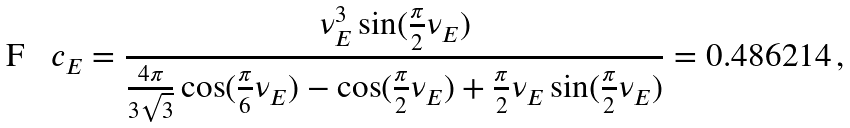<formula> <loc_0><loc_0><loc_500><loc_500>c _ { E } = \frac { \nu ^ { 3 } _ { E } \sin ( \frac { \pi } { 2 } \nu _ { E } ) } { \frac { 4 \pi } { 3 \sqrt { 3 } } \cos ( \frac { \pi } { 6 } \nu _ { E } ) - \cos ( \frac { \pi } { 2 } \nu _ { E } ) + \frac { \pi } { 2 } \nu _ { E } \sin ( \frac { \pi } { 2 } \nu _ { E } ) } = 0 . 4 8 6 2 1 4 \, ,</formula> 